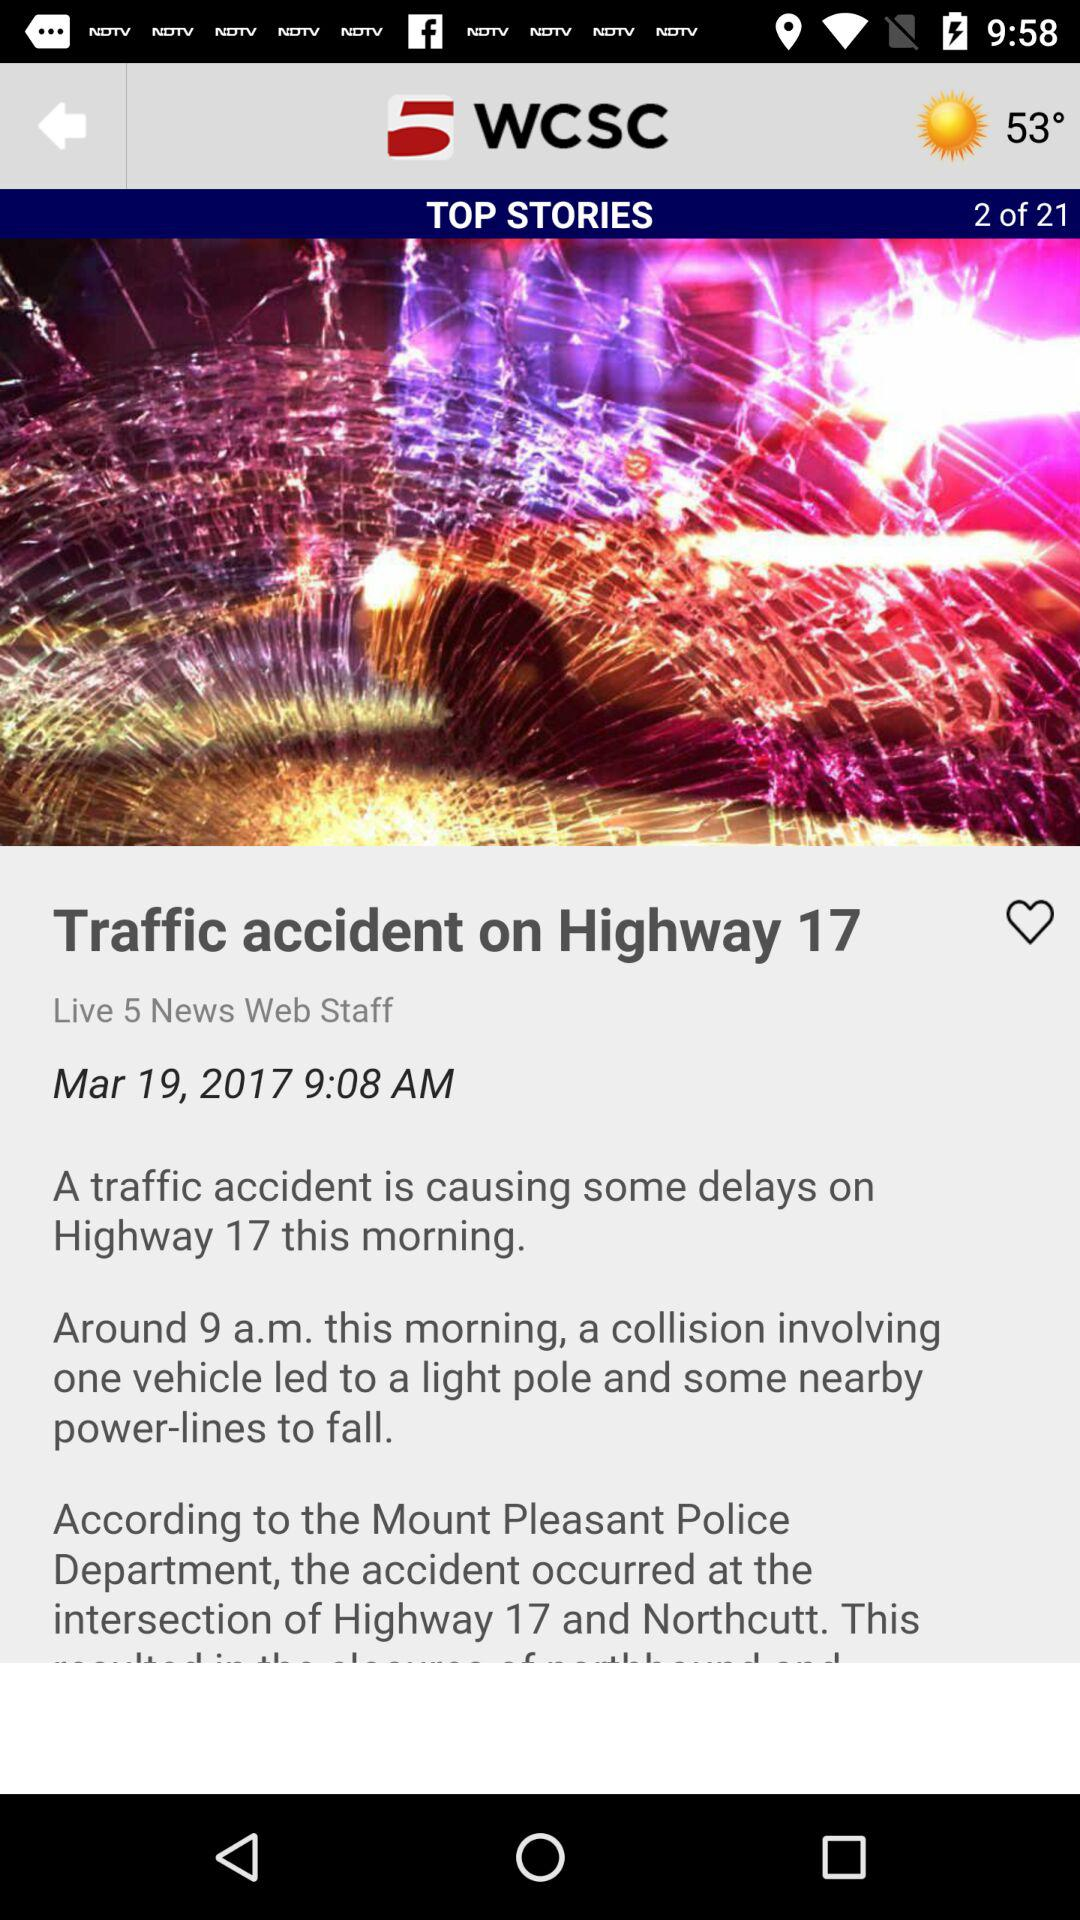What is the date? The date is March 19, 2017. 